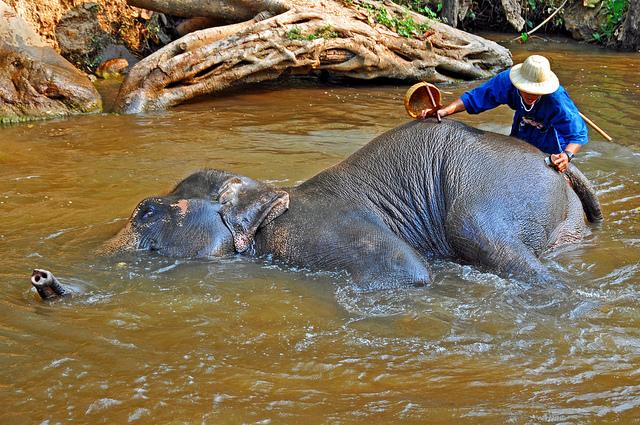Is the elephant happy?
Be succinct. Yes. Is the elephant drowning?
Quick response, please. No. What is the man holding?
Be succinct. Basket. Is this a household pet?
Keep it brief. No. Is this muddy water?
Quick response, please. Yes. 